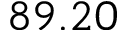Convert formula to latex. <formula><loc_0><loc_0><loc_500><loc_500>8 9 . 2 0</formula> 